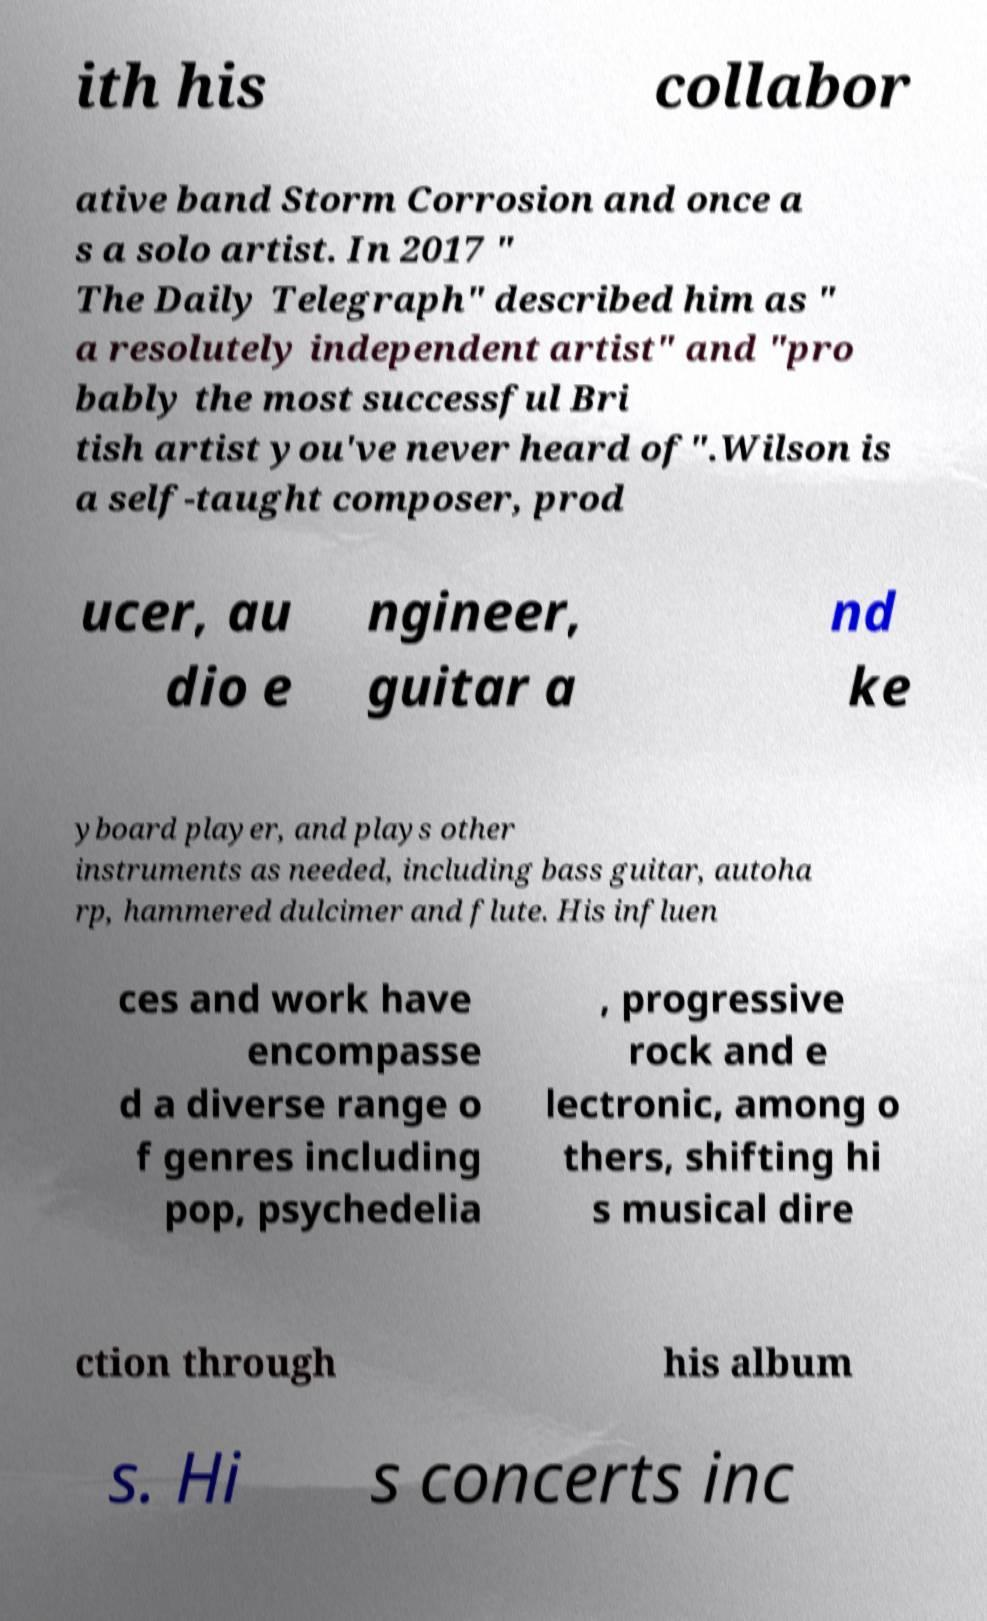What messages or text are displayed in this image? I need them in a readable, typed format. ith his collabor ative band Storm Corrosion and once a s a solo artist. In 2017 " The Daily Telegraph" described him as " a resolutely independent artist" and "pro bably the most successful Bri tish artist you've never heard of".Wilson is a self-taught composer, prod ucer, au dio e ngineer, guitar a nd ke yboard player, and plays other instruments as needed, including bass guitar, autoha rp, hammered dulcimer and flute. His influen ces and work have encompasse d a diverse range o f genres including pop, psychedelia , progressive rock and e lectronic, among o thers, shifting hi s musical dire ction through his album s. Hi s concerts inc 